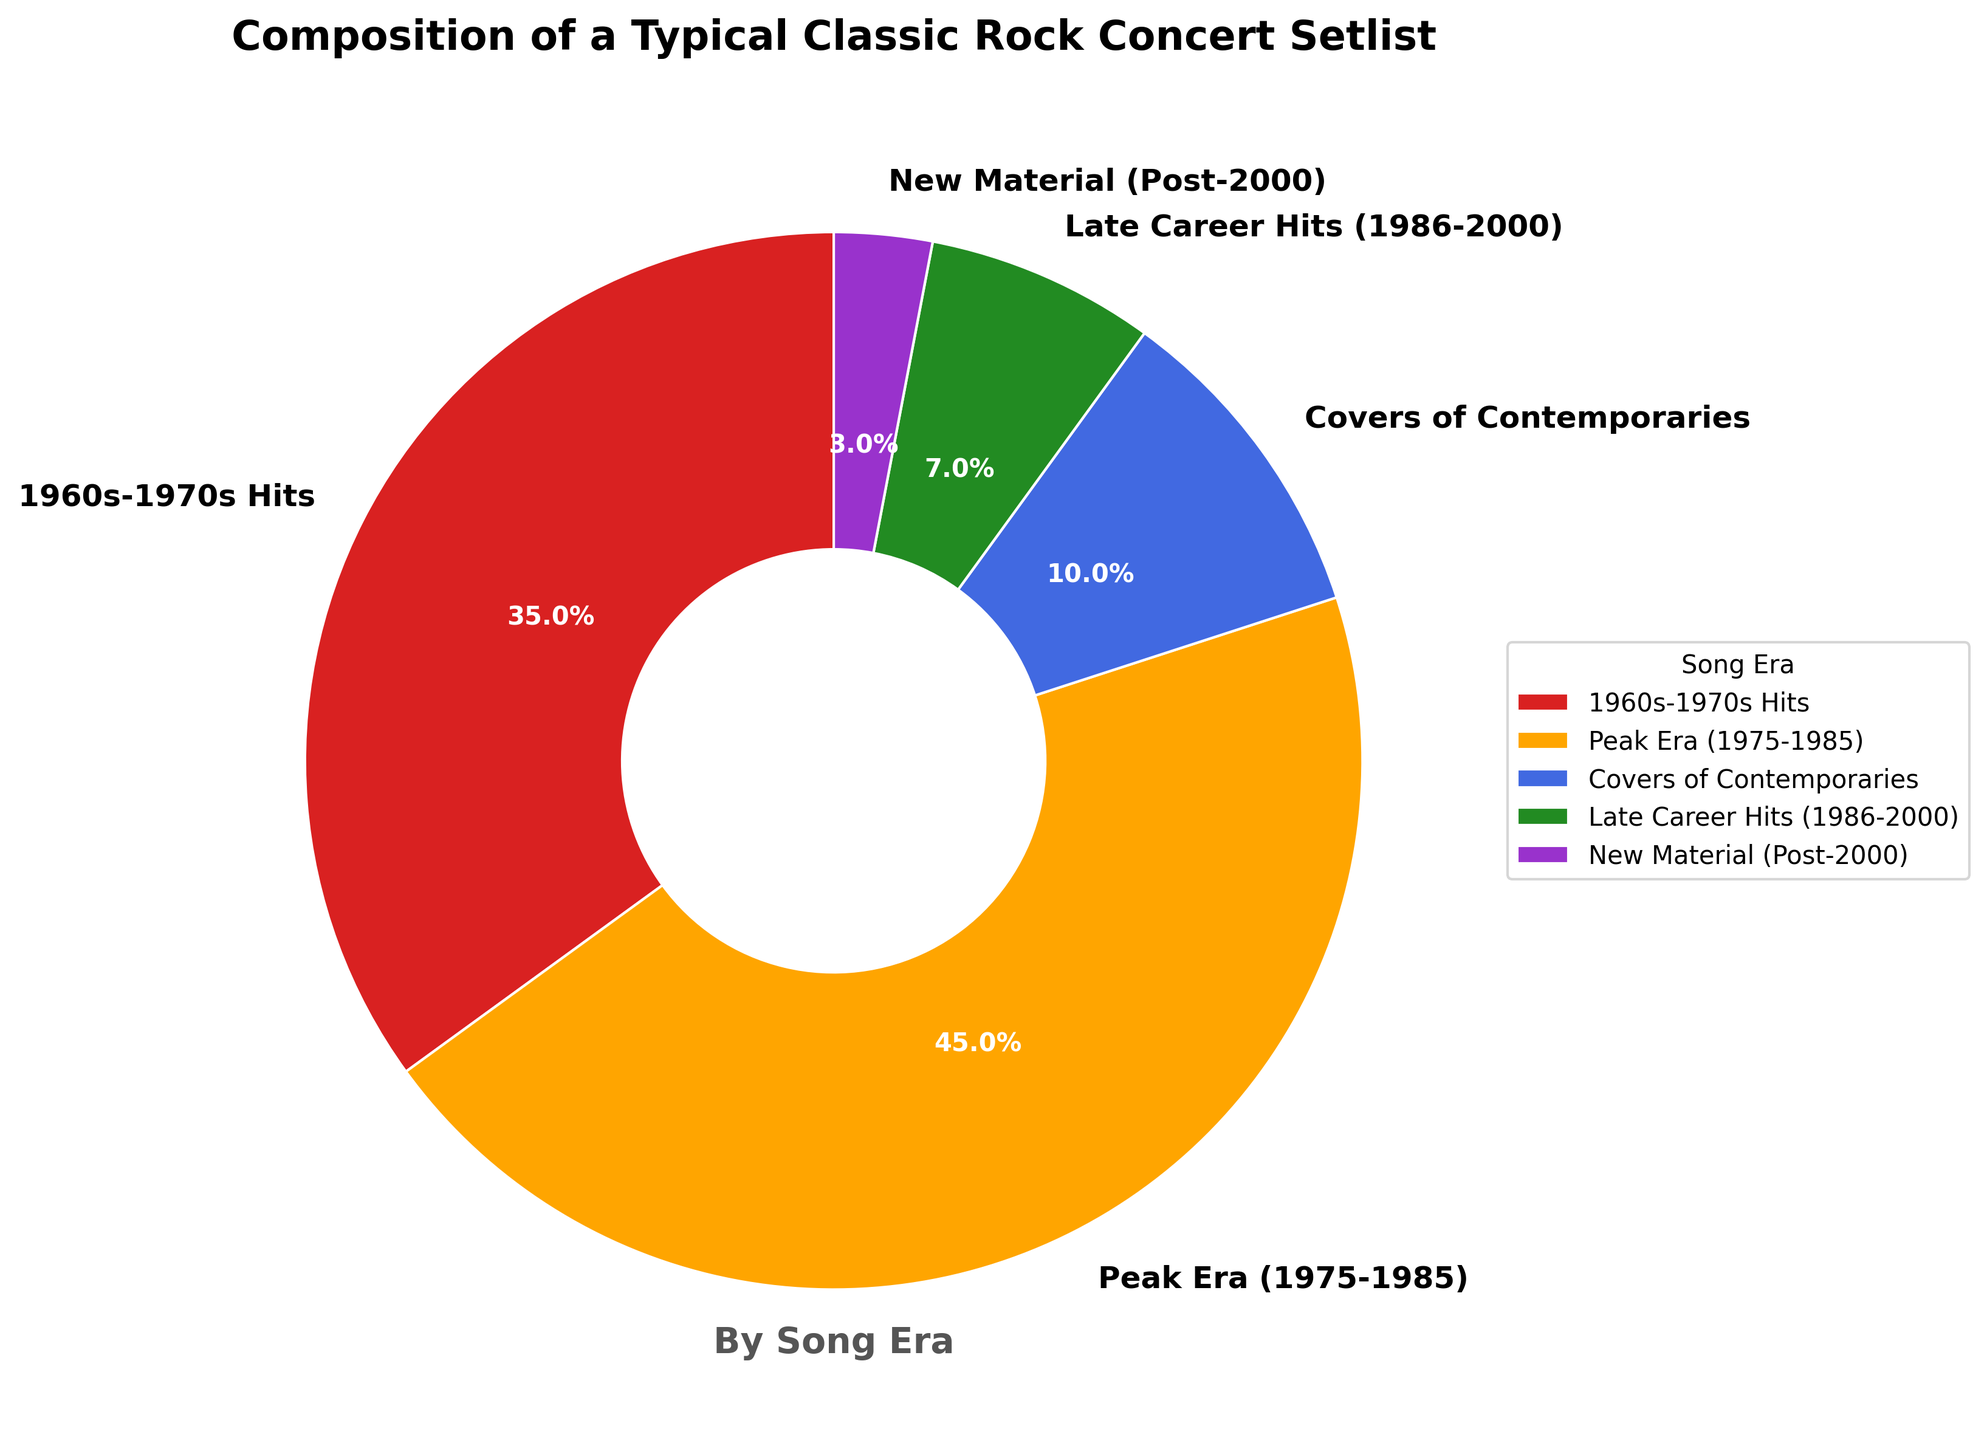What percentage of the song setlist consists of hits from the 1960s-1970s? The "1960s-1970s Hits" section of the pie chart represents the percentage of the setlist from this era.
Answer: 35% How does the percentage of songs from the band's peak era (1975-1985) compare to the percentage of covers of contemporaries? The chart shows that the "Peak Era (1975-1985)" is 45%, while "Covers of Contemporaries" is 10%. Therefore, the "Peak Era" percentage is greater.
Answer: Peak Era has 35% more Which song era has the smallest representation in the setlist? From the pie chart, the "New Material (Post-2000)" section is the smallest, indicating it has the smallest percentage.
Answer: New Material (Post-2000) What is the combined percentage of late career hits (1986-2000) and new material (Post-2000)? The percentage of "Late Career Hits (1986-2000)" is 7%, and "New Material (Post-2000)" is 3%. Adding these together gives 7% + 3% = 10%.
Answer: 10% Compare the visual size of the wedge representing covers of contemporaries to the size of the wedge for late career hits. The wedge for "Covers of Contemporaries" appears larger than the wedge for "Late Career Hits (1986-2000)" in the pie chart.
Answer: Covers of Contemporaries is larger Is the percentage of hits from the 1960s-1970s greater than the combined percentage of late career hits (1986-2000) and new material (Post-2000)? The percentage of "1960s-1970s Hits" is 35%. The combined percentage of "Late Career Hits (1986-2000)" and "New Material (Post-2000)" is 10%. Since 35% is greater than 10%, this is true.
Answer: Yes What song era has the second largest percentage in the setlist? The second largest section in the pie chart is the "1960s-1970s Hits," which is 35%. The largest is "Peak Era (1975-1985)" at 45%.
Answer: 1960s-1970s Hits What is the difference in percentage between the band's hits from their peak era (1975-1985) and new material (Post-2000)? The "Peak Era (1975-1985)" has 45% and "New Material (Post-2000)" has 3%. The difference is 45% - 3% = 42%.
Answer: 42% Do the hits from the 1960s-1970s and the peak era together represent more than half of the setlist? Adding the percentages for "1960s-1970s Hits" (35%) and "Peak Era (1975-1985)" (45%) gives 35% + 45% = 80%, which is more than half of the setlist.
Answer: Yes Identify the color representing the New Material (Post-2000) in the pie chart. Based on the order of the data provided and coloring sequence, "New Material (Post-2000)" is represented by the purple color.
Answer: Purple 